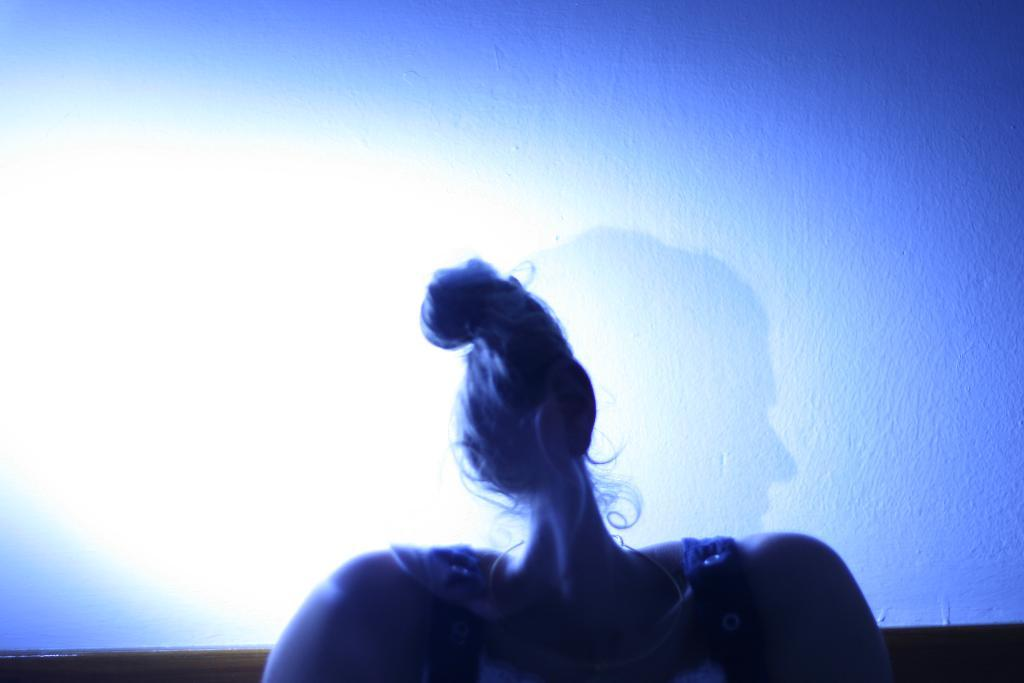What can be observed about the image? The image is edited. What is visible on the wall in the image? There is a shadow of a person's head on the wall. How does the image increase the size of the shadow on the wall? The image does not increase the size of the shadow on the wall; the shadow is a result of the person's head blocking light and casting a natural shadow on the wall. 